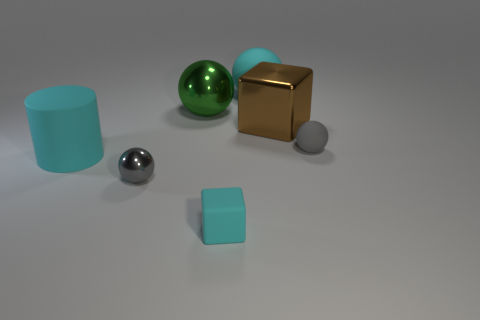How big is the rubber object behind the tiny object that is on the right side of the large metallic object to the right of the cyan block?
Offer a terse response. Large. What material is the large cyan thing right of the rubber cube in front of the big matte ball?
Ensure brevity in your answer.  Rubber. Is there another tiny object that has the same shape as the brown metallic object?
Your answer should be very brief. Yes. What is the shape of the small cyan object?
Offer a terse response. Cube. There is a large sphere left of the matte thing that is in front of the gray sphere to the left of the green shiny ball; what is its material?
Give a very brief answer. Metal. Are there more large brown things in front of the big cyan matte cylinder than cyan things?
Ensure brevity in your answer.  No. What is the material of the green object that is the same size as the brown thing?
Provide a succinct answer. Metal. Are there any green objects of the same size as the cyan block?
Provide a succinct answer. No. What size is the cyan rubber thing right of the tiny cyan rubber block?
Make the answer very short. Large. What size is the cyan matte cylinder?
Ensure brevity in your answer.  Large. 